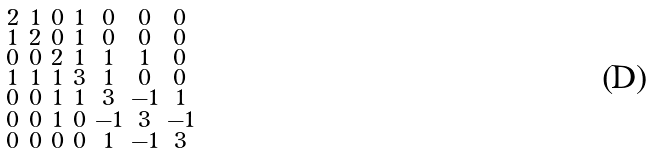<formula> <loc_0><loc_0><loc_500><loc_500>\begin{smallmatrix} 2 & 1 & 0 & 1 & 0 & 0 & 0 \\ 1 & 2 & 0 & 1 & 0 & 0 & 0 \\ 0 & 0 & 2 & 1 & 1 & 1 & 0 \\ 1 & 1 & 1 & 3 & 1 & 0 & 0 \\ 0 & 0 & 1 & 1 & 3 & - 1 & 1 \\ 0 & 0 & 1 & 0 & - 1 & 3 & - 1 \\ 0 & 0 & 0 & 0 & 1 & - 1 & 3 \end{smallmatrix}</formula> 